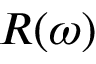<formula> <loc_0><loc_0><loc_500><loc_500>R ( \omega )</formula> 